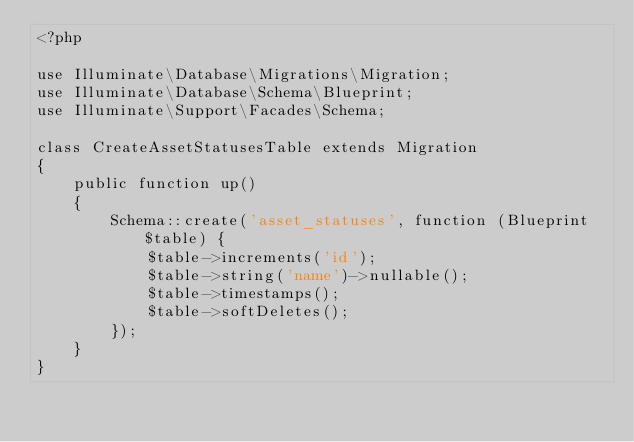Convert code to text. <code><loc_0><loc_0><loc_500><loc_500><_PHP_><?php

use Illuminate\Database\Migrations\Migration;
use Illuminate\Database\Schema\Blueprint;
use Illuminate\Support\Facades\Schema;

class CreateAssetStatusesTable extends Migration
{
    public function up()
    {
        Schema::create('asset_statuses', function (Blueprint $table) {
            $table->increments('id');
            $table->string('name')->nullable();
            $table->timestamps();
            $table->softDeletes();
        });
    }
}
</code> 